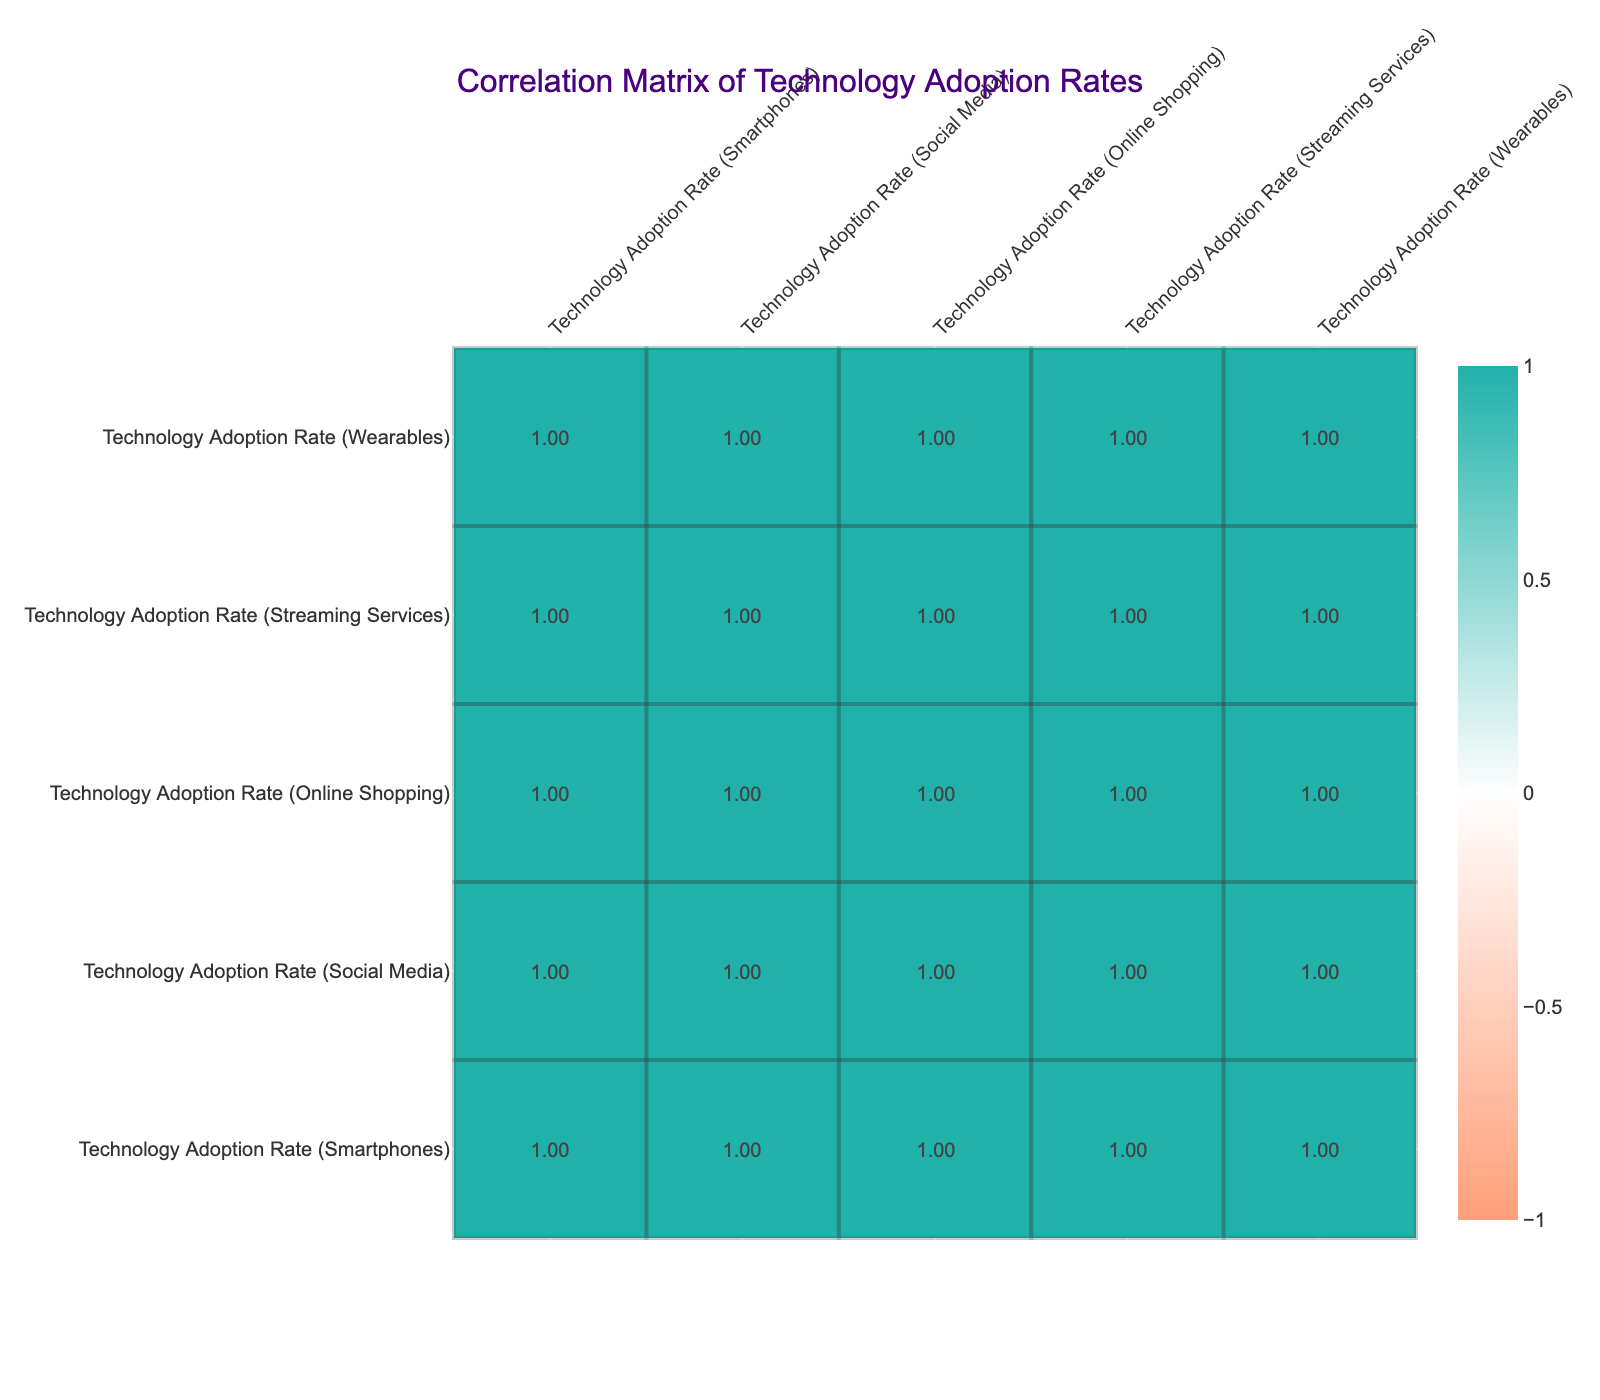What is the technology adoption rate for the 45-54 age group in streaming services? According to the table, the value corresponding to the age group 45-54 under the column for streaming services is 55.
Answer: 55 What is the technology adoption rate for online shopping among the 55-64 age group? The table shows that the online shopping adoption rate for the age group 55-64 is 45.
Answer: 45 Which age group has the highest technology adoption rate for smartphones? By examining the smartphone adoption rates, the age group 18-24 exhibits the highest rate at 95.
Answer: 18-24 Is the technology adoption rate for wearables higher in the 35-44 age group than in the 25-34 age group? The table indicates that the wearables adoption rate for the 35-44 age group is 60, while for the 25-34 age group it is 65. Since 60 is less than 65, the statement is false.
Answer: No What is the difference in technology adoption rates for social media between the 25-34 age group and the 55-64 age group? The social media adoption rate is 85 for the 25-34 age group and 50 for the 55-64 age group. The difference is 85 - 50 = 35.
Answer: 35 What is the average technology adoption rate for all types of technology among the 65+ age group? For the 65+ age group, the rates are 40 for smartphones, 30 for social media, 25 for online shopping, 20 for streaming services, and 15 for wearables. Summing these values gives 40 + 30 + 25 + 20 + 15 = 130. There are 5 technologies, so the average is 130/5 = 26.
Answer: 26 Does the adoption rate for online shopping increase as the age group decreases? Checking the online shopping rates, we can see that they are 85 (18-24), 80 (25-34), 70 (35-44), 60 (45-54), 45 (55-64), and 25 (65+). Since the rates decrease, the statement is false.
Answer: No Which age group has the lowest rate of technology adoption for streaming services? Examining the streaming services row, it is clear that the age group 65+ has the lowest adoption rate at 20.
Answer: 65+ What is the technology adoption rate for smartphones in the 35-44 age group compared to the 55-64 age group? In the 35-44 age group, the adoption rate for smartphones is 85, while in the 55-64 age group it is 60. Thus, 85 is greater than 60.
Answer: 85 compared to 60 